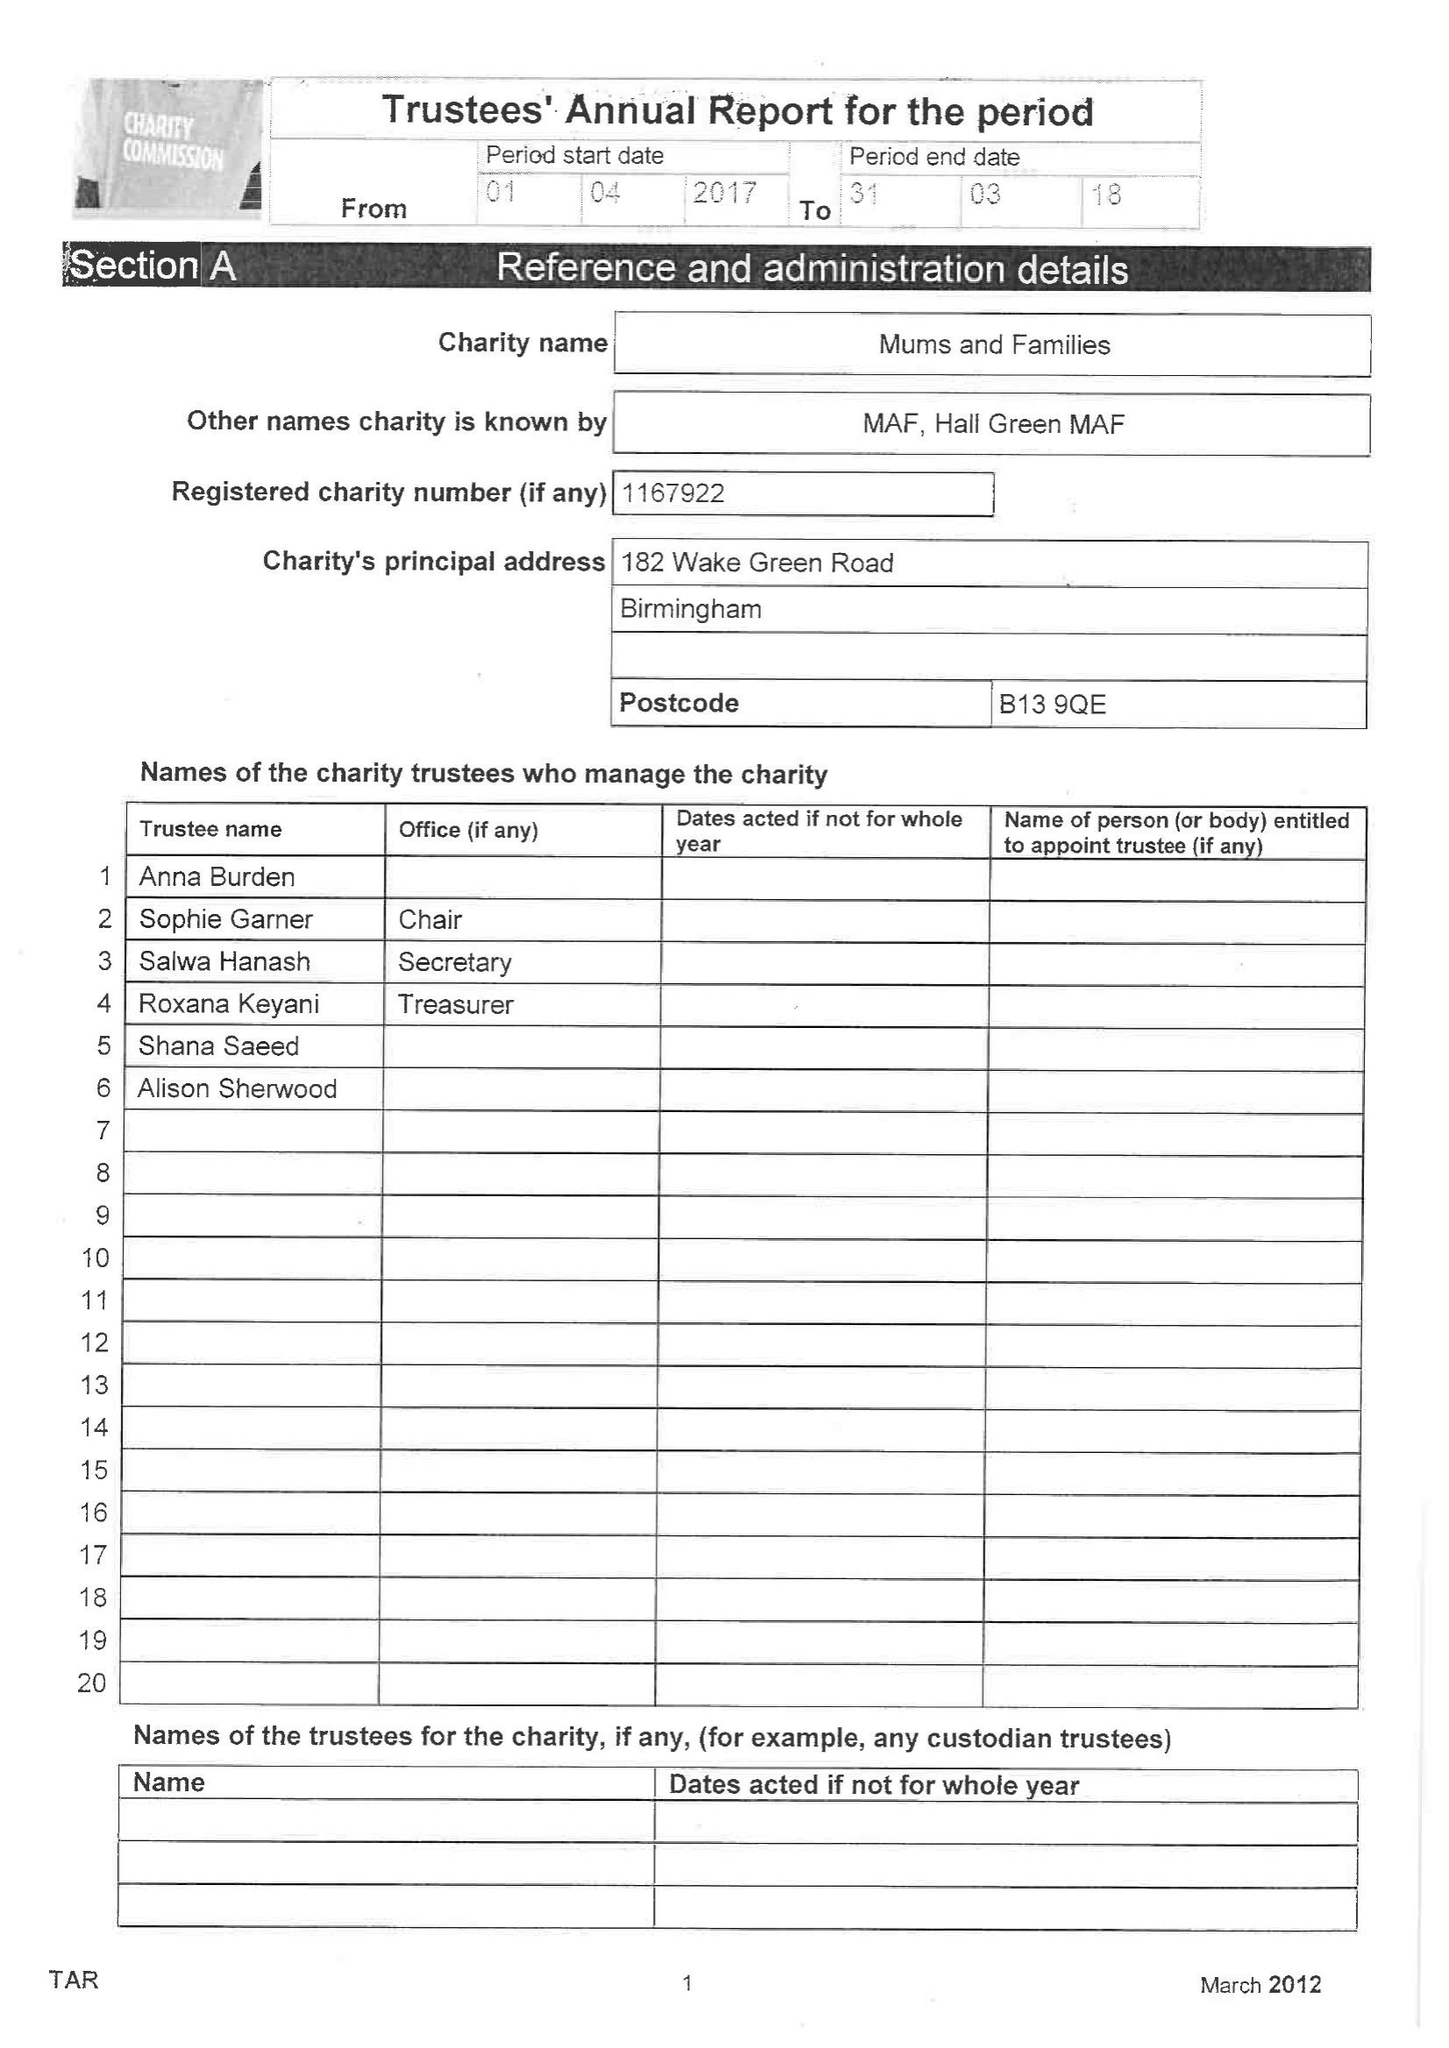What is the value for the income_annually_in_british_pounds?
Answer the question using a single word or phrase. 1326.00 